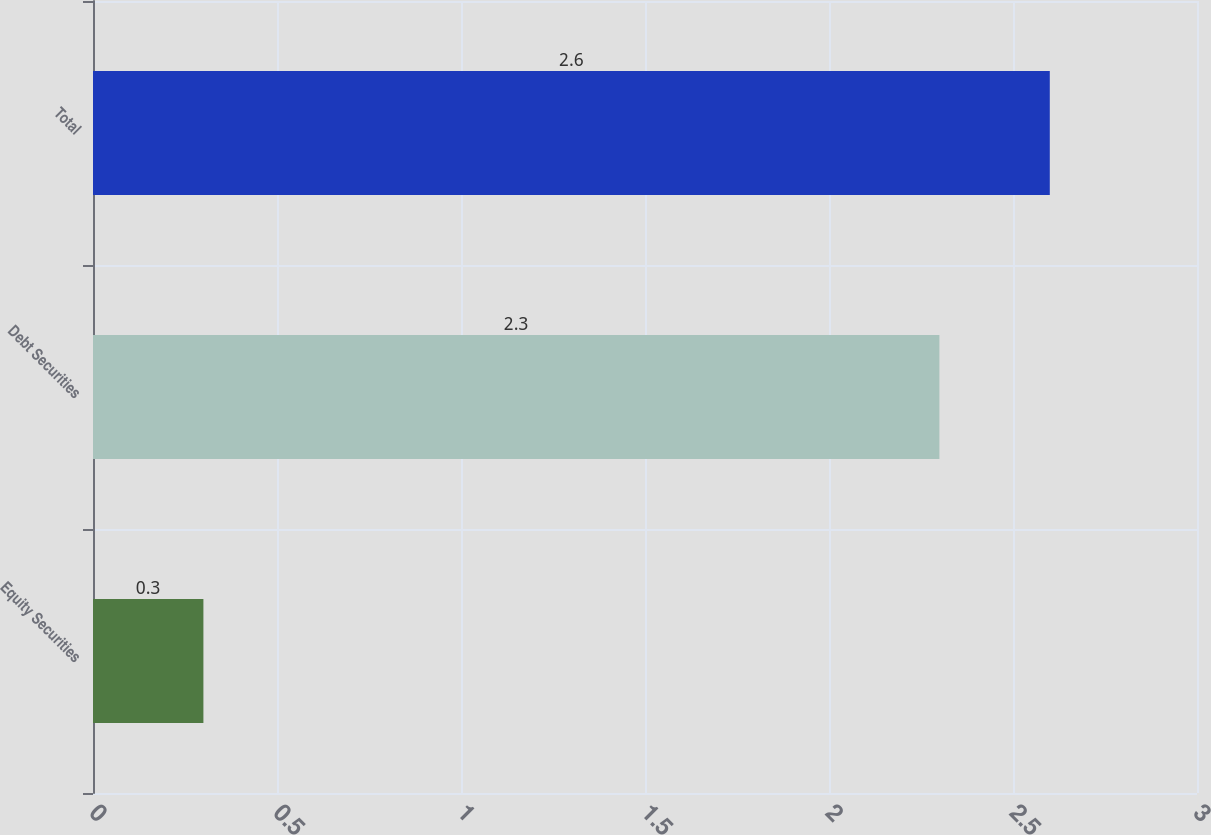Convert chart. <chart><loc_0><loc_0><loc_500><loc_500><bar_chart><fcel>Equity Securities<fcel>Debt Securities<fcel>Total<nl><fcel>0.3<fcel>2.3<fcel>2.6<nl></chart> 